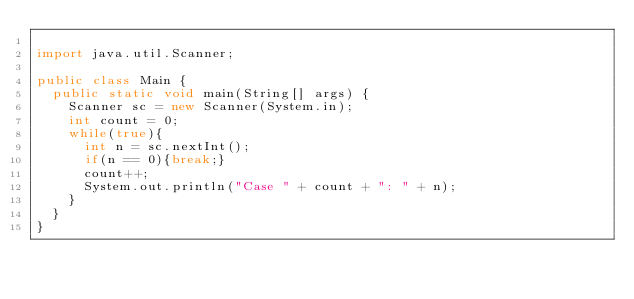<code> <loc_0><loc_0><loc_500><loc_500><_Java_>
import java.util.Scanner;

public class Main {
	public static void main(String[] args) {
		Scanner sc = new Scanner(System.in);
		int count = 0;
		while(true){
			int n = sc.nextInt();
			if(n == 0){break;}
			count++;
			System.out.println("Case " + count + ": " + n);
		}
	}
}

</code> 